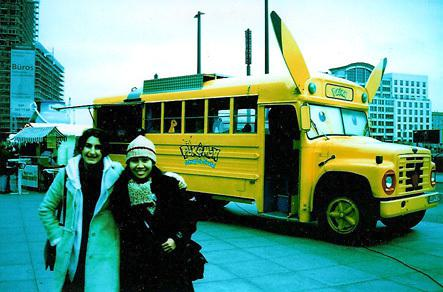Is there a bus in the image? Yes, there is a yellow bus in the image, which appears to be styled with an iconic theme, possibly for promotional purposes, given the bright colors and recognizable design elements visible. 